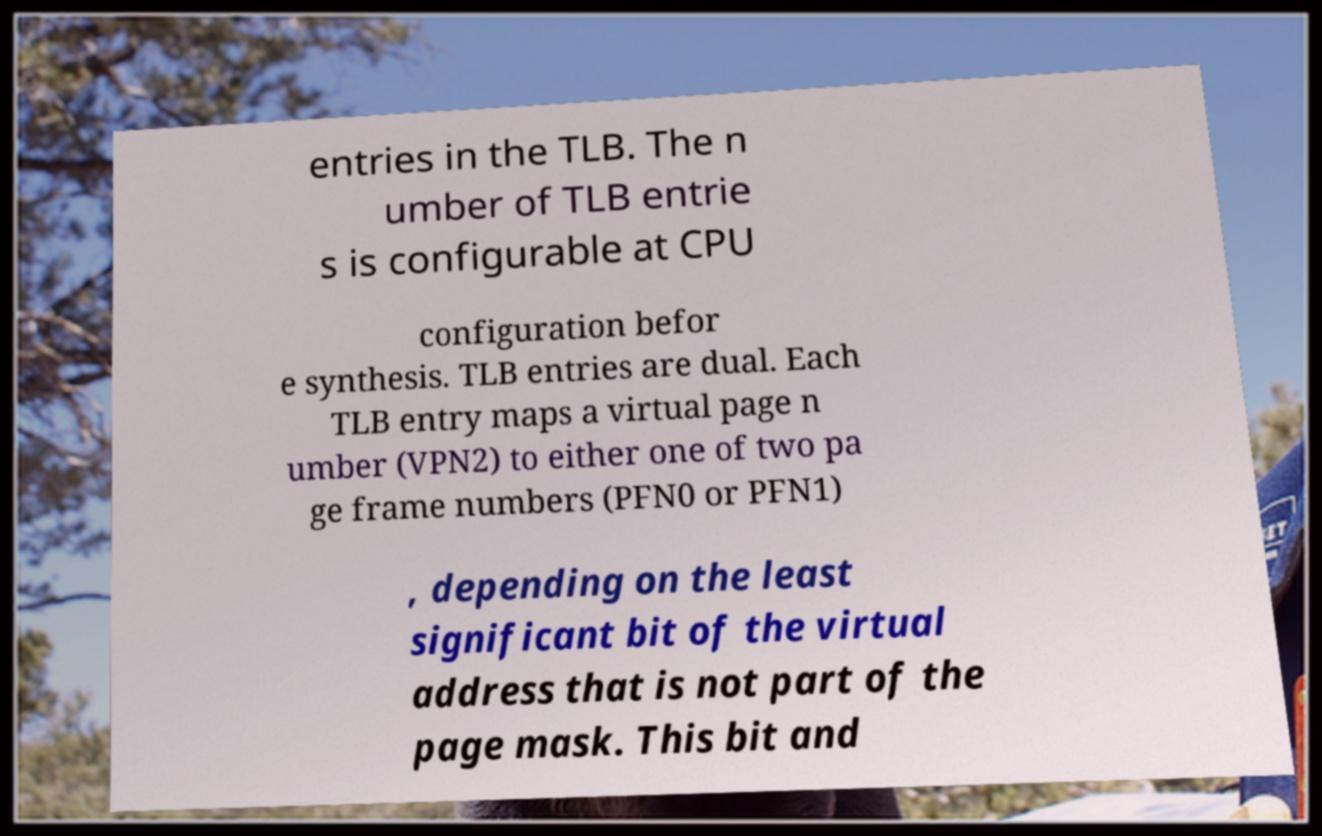What messages or text are displayed in this image? I need them in a readable, typed format. entries in the TLB. The n umber of TLB entrie s is configurable at CPU configuration befor e synthesis. TLB entries are dual. Each TLB entry maps a virtual page n umber (VPN2) to either one of two pa ge frame numbers (PFN0 or PFN1) , depending on the least significant bit of the virtual address that is not part of the page mask. This bit and 